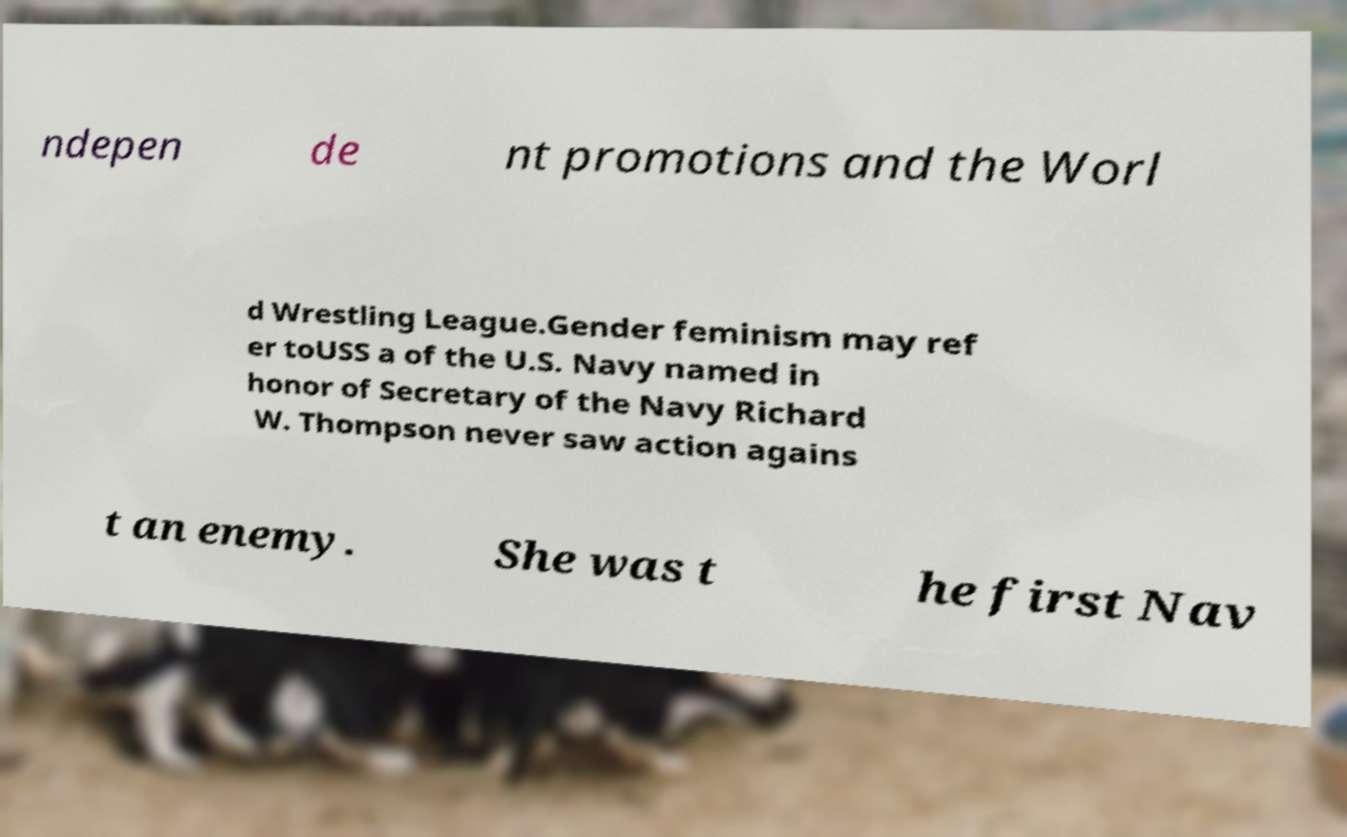Can you accurately transcribe the text from the provided image for me? ndepen de nt promotions and the Worl d Wrestling League.Gender feminism may ref er toUSS a of the U.S. Navy named in honor of Secretary of the Navy Richard W. Thompson never saw action agains t an enemy. She was t he first Nav 